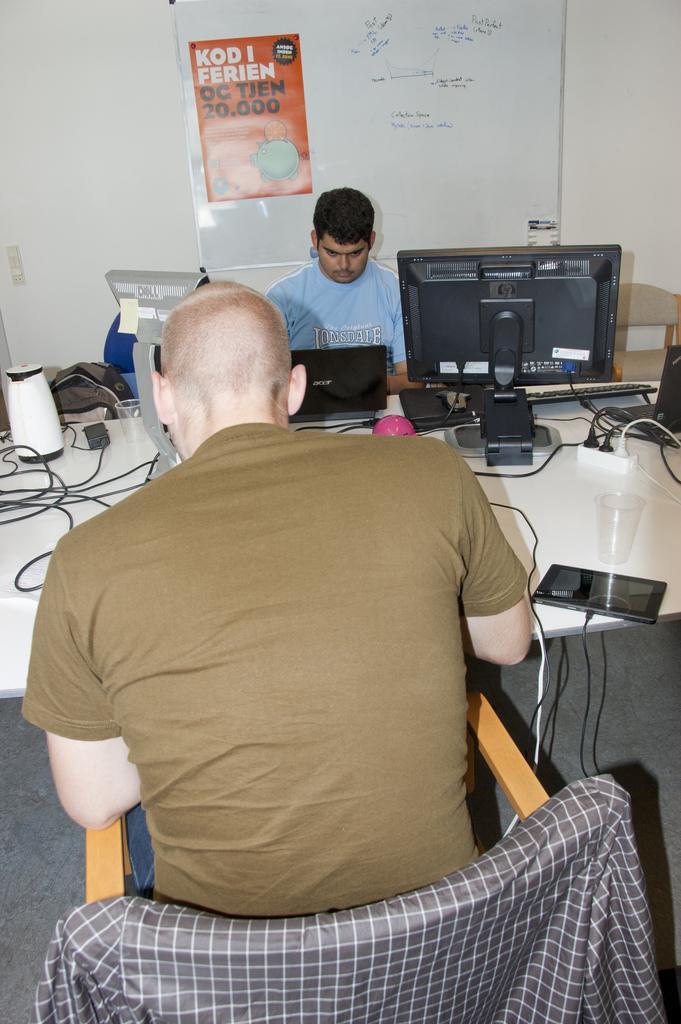In one or two sentences, can you explain what this image depicts? In this image I can see two people are sitting on the chairs. In front I can see the system, laptop, wires and few objects on the table. Back I can see a white color board is attached to the white wall. 